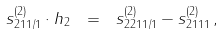Convert formula to latex. <formula><loc_0><loc_0><loc_500><loc_500>s ^ { ( 2 ) } _ { 2 1 1 / 1 } \cdot h _ { 2 } \ = \ s ^ { ( 2 ) } _ { 2 2 1 1 / 1 } - s ^ { ( 2 ) } _ { 2 1 1 1 } \, ,</formula> 